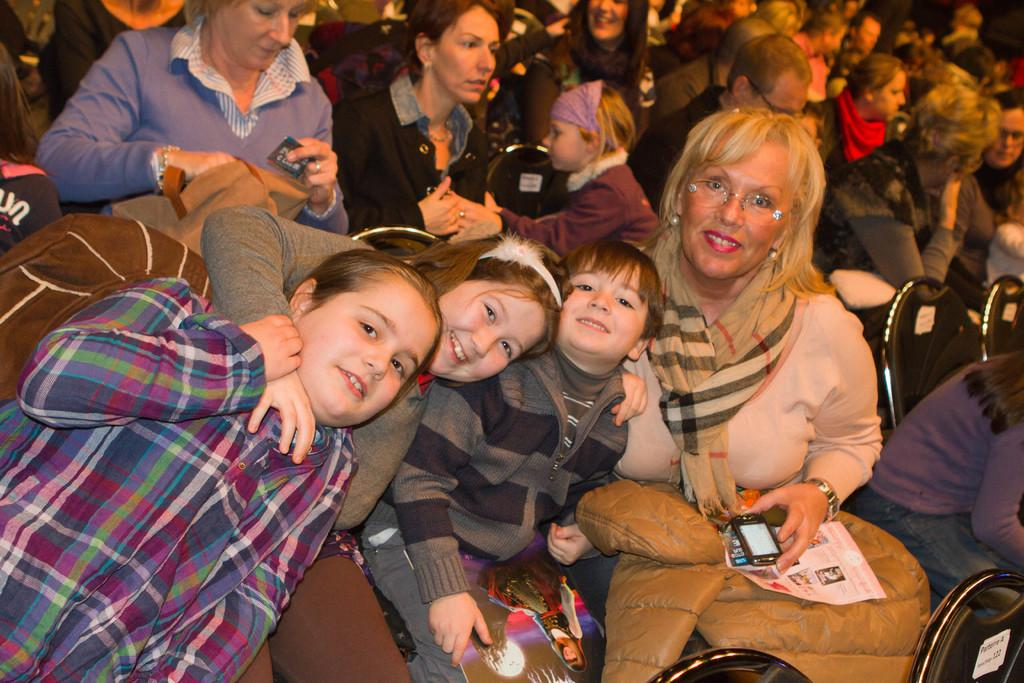What is happening in the image involving a group of people? There is a group of people in the image, and they are sitting on chairs. How are the people in the front depicted? The people in the front are smiling. What object can be seen in the image besides the people? There is a mobile in the image. What type of clothing is the woman wearing? A woman is wearing a jacket in the image. How many balloons are being held by the person in the image? There are no balloons present in the image. How many women are wearing hats in the image? There is no mention of hats or the number of women wearing them in the image. 